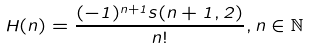Convert formula to latex. <formula><loc_0><loc_0><loc_500><loc_500>H ( n ) = \frac { ( - 1 ) ^ { n + 1 } s ( n + 1 , 2 ) } { n ! } , n \in \mathbb { N }</formula> 